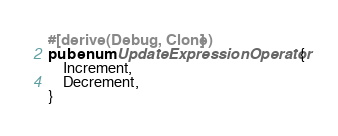Convert code to text. <code><loc_0><loc_0><loc_500><loc_500><_Rust_>
#[derive(Debug, Clone)]
pub enum UpdateExpressionOperator {
    Increment,
    Decrement,
}
</code> 